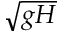<formula> <loc_0><loc_0><loc_500><loc_500>\sqrt { g H }</formula> 